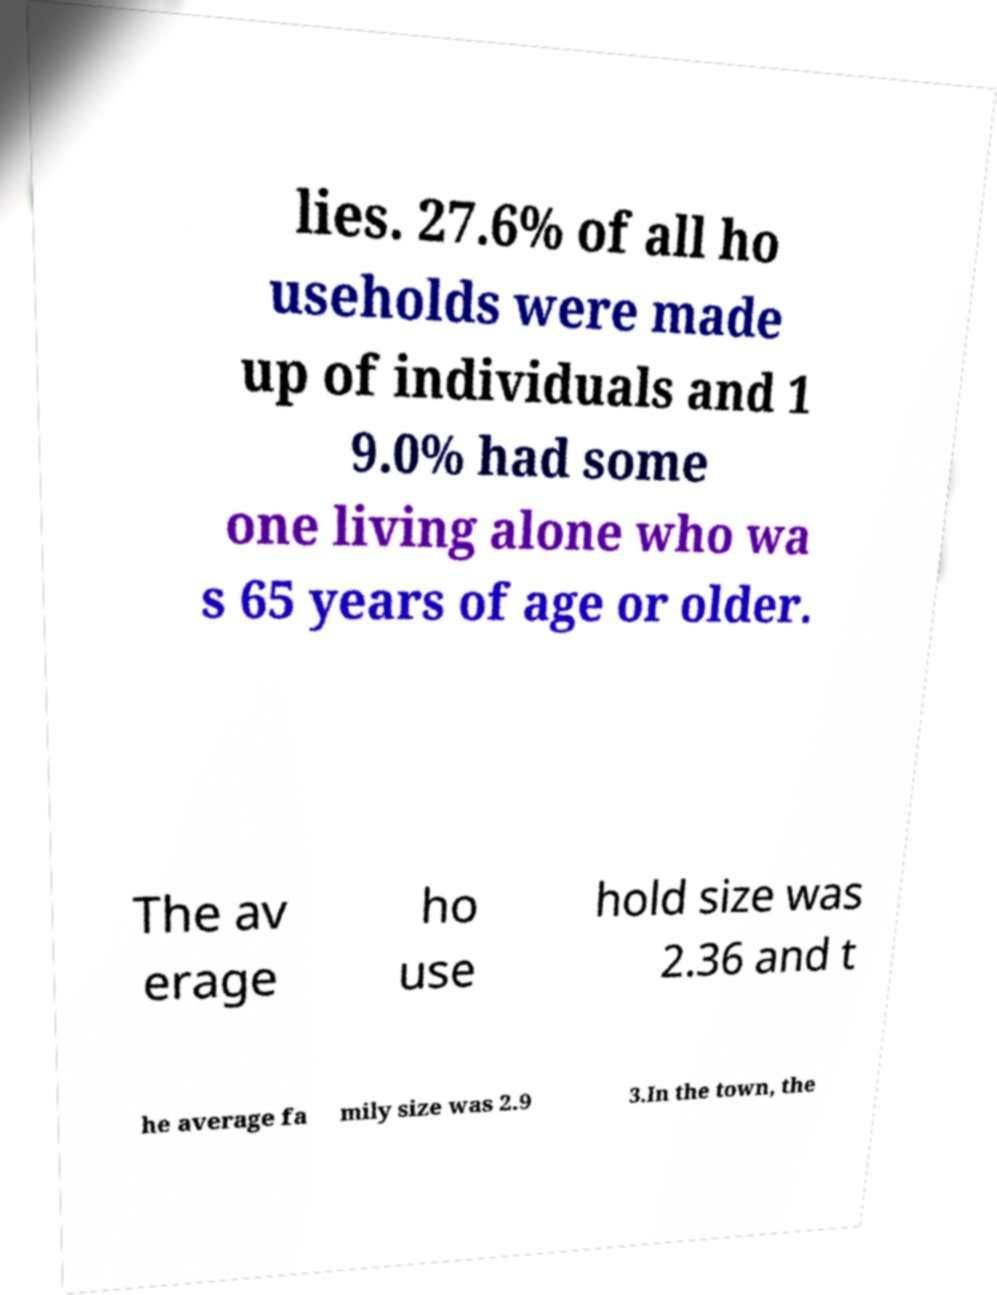Could you extract and type out the text from this image? lies. 27.6% of all ho useholds were made up of individuals and 1 9.0% had some one living alone who wa s 65 years of age or older. The av erage ho use hold size was 2.36 and t he average fa mily size was 2.9 3.In the town, the 